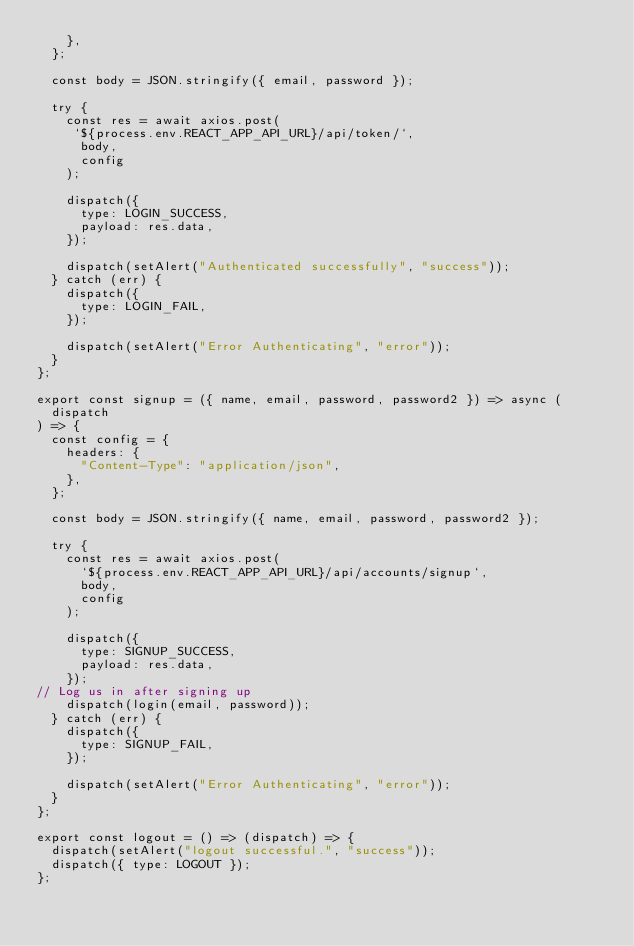Convert code to text. <code><loc_0><loc_0><loc_500><loc_500><_JavaScript_>    },
  };

  const body = JSON.stringify({ email, password });

  try {
    const res = await axios.post(
     `${process.env.REACT_APP_API_URL}/api/token/`,
      body,
      config
    );

    dispatch({
      type: LOGIN_SUCCESS,
      payload: res.data,
    });

    dispatch(setAlert("Authenticated successfully", "success"));
  } catch (err) {
    dispatch({
      type: LOGIN_FAIL,
    });

    dispatch(setAlert("Error Authenticating", "error"));
  }
};

export const signup = ({ name, email, password, password2 }) => async (
  dispatch
) => {
  const config = {
    headers: {
      "Content-Type": "application/json",
    },
  };

  const body = JSON.stringify({ name, email, password, password2 });

  try {
    const res = await axios.post(
      `${process.env.REACT_APP_API_URL}/api/accounts/signup`,
      body,
      config
    );

    dispatch({
      type: SIGNUP_SUCCESS,
      payload: res.data,
    });
// Log us in after signing up
    dispatch(login(email, password));
  } catch (err) {
    dispatch({
      type: SIGNUP_FAIL,
    });

    dispatch(setAlert("Error Authenticating", "error"));
  }
};

export const logout = () => (dispatch) => {
  dispatch(setAlert("logout successful.", "success"));
  dispatch({ type: LOGOUT });
};
</code> 